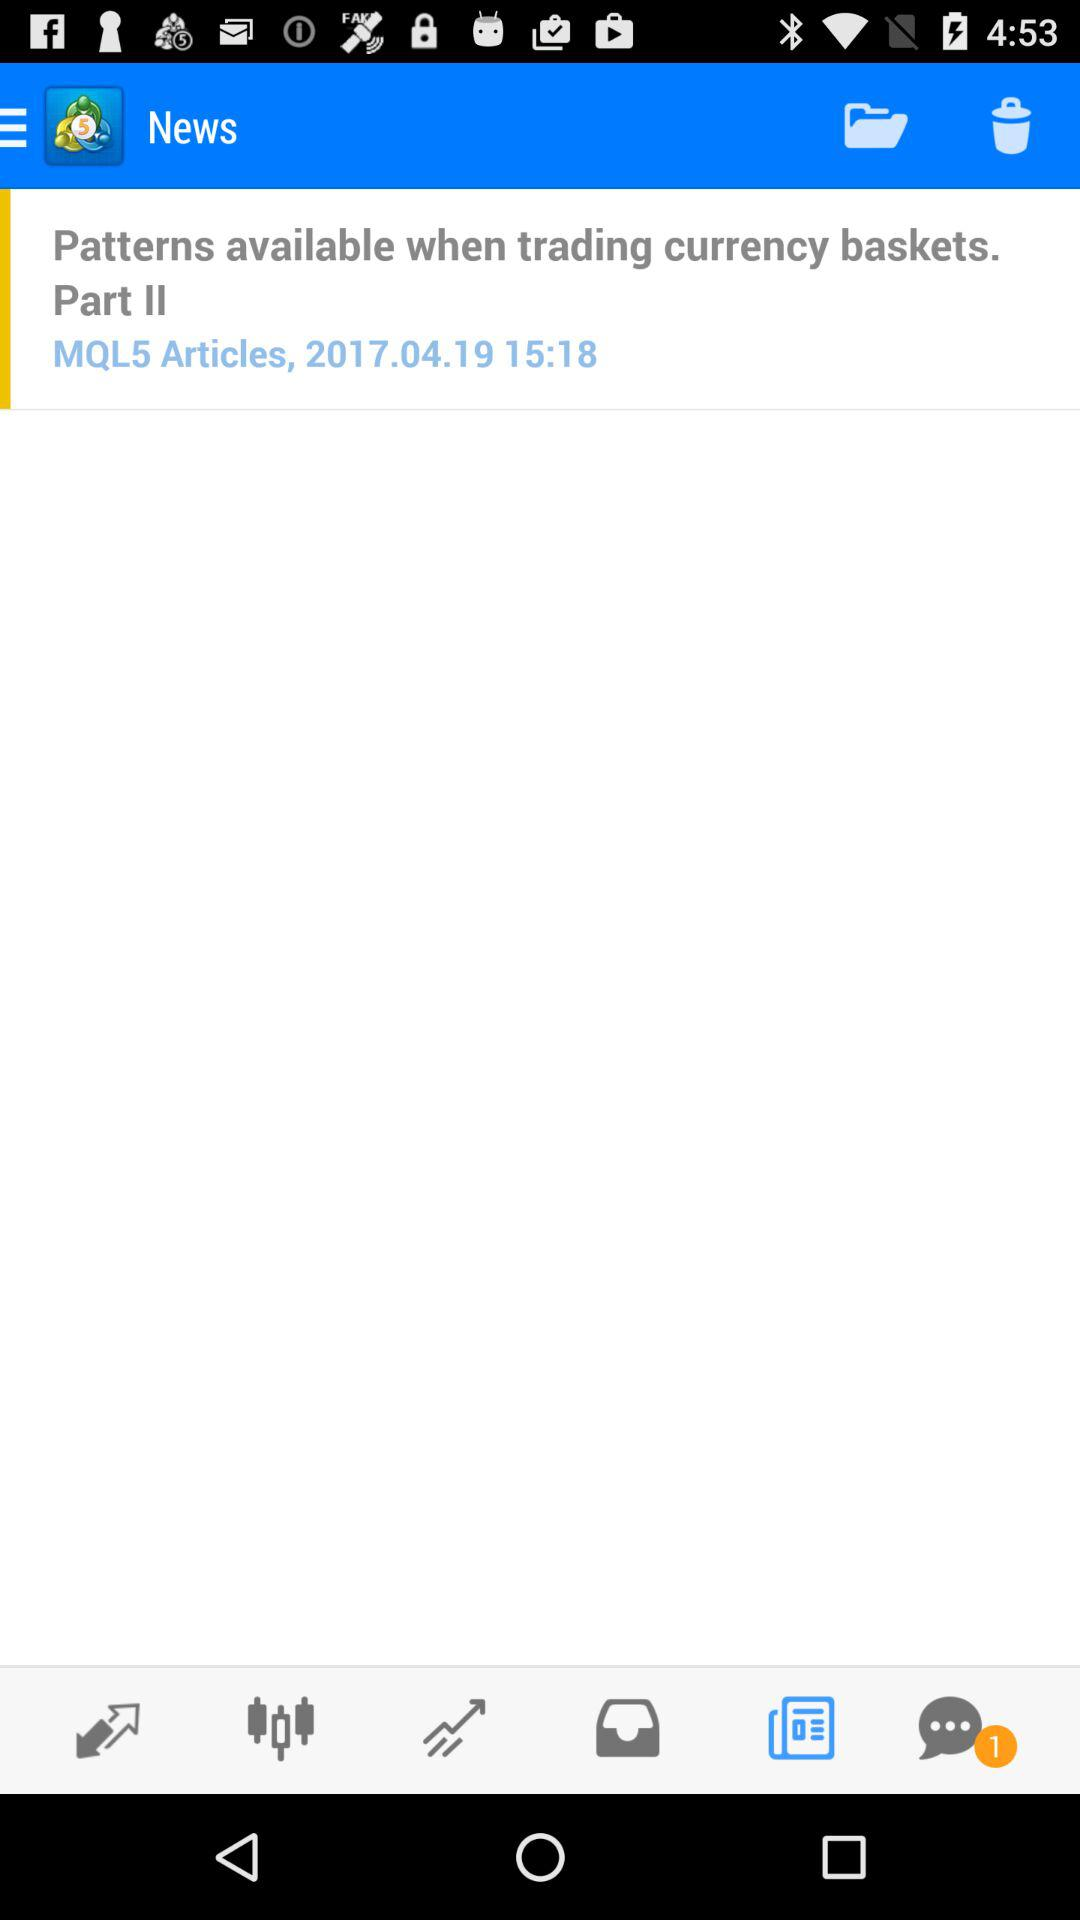What is the posted date of "Patterns available when trading currency baskets. Part II"? The posted date of "Patterns available when trading currency baskets. Part II" is April 19, 2017. 